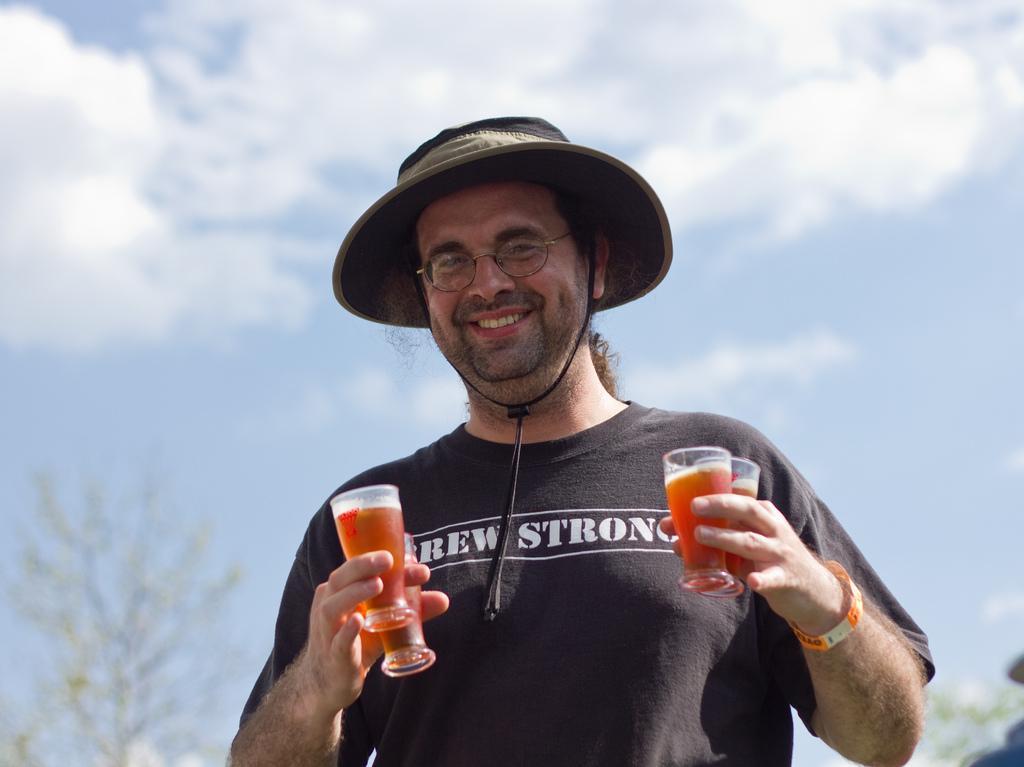In one or two sentences, can you explain what this image depicts? In the picture we can see a man standing holding a four glasses with drink and he is wearing a black T-shirt with a wordings REW STRONG, he is wearing a hat which is black in color and band to the hand which is orange and white in color, in the background we can see a sky with clouds and some plants. 